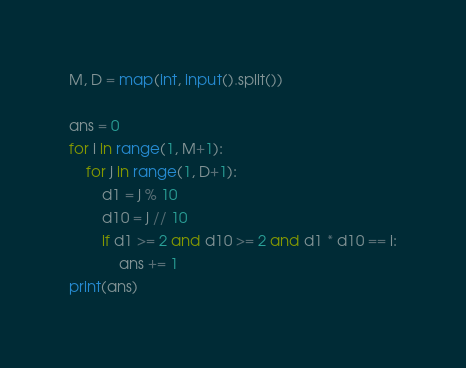Convert code to text. <code><loc_0><loc_0><loc_500><loc_500><_Python_>M, D = map(int, input().split())

ans = 0
for i in range(1, M+1):
    for j in range(1, D+1):
        d1 = j % 10
        d10 = j // 10
        if d1 >= 2 and d10 >= 2 and d1 * d10 == i:
            ans += 1
print(ans)
</code> 